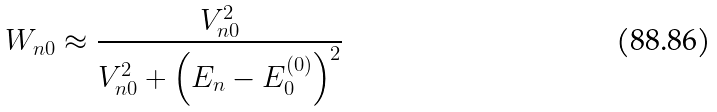Convert formula to latex. <formula><loc_0><loc_0><loc_500><loc_500>W _ { n 0 } \approx \frac { V _ { n 0 } ^ { 2 } } { V _ { n 0 } ^ { 2 } + \left ( E _ { n } - E _ { 0 } ^ { ( 0 ) } \right ) ^ { 2 } }</formula> 